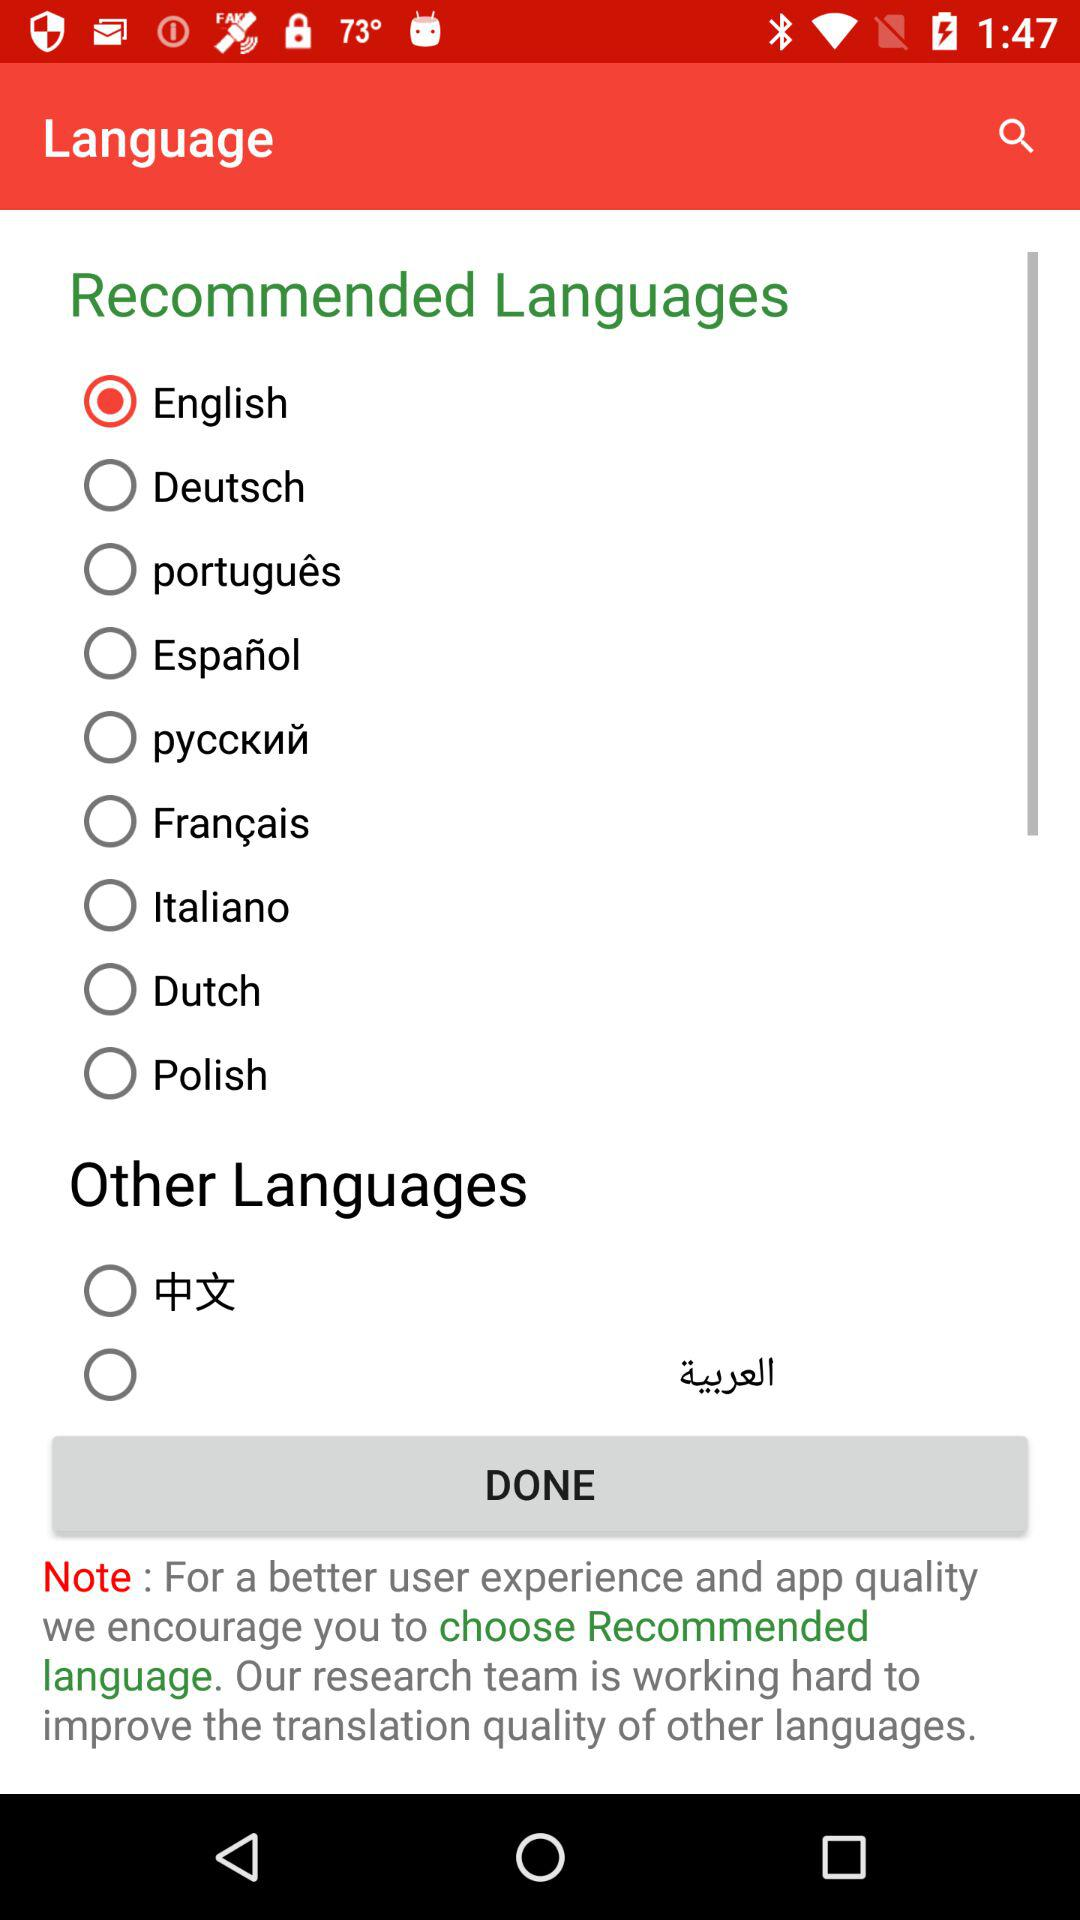How many languages are there in the Other Languages section?
Answer the question using a single word or phrase. 2 